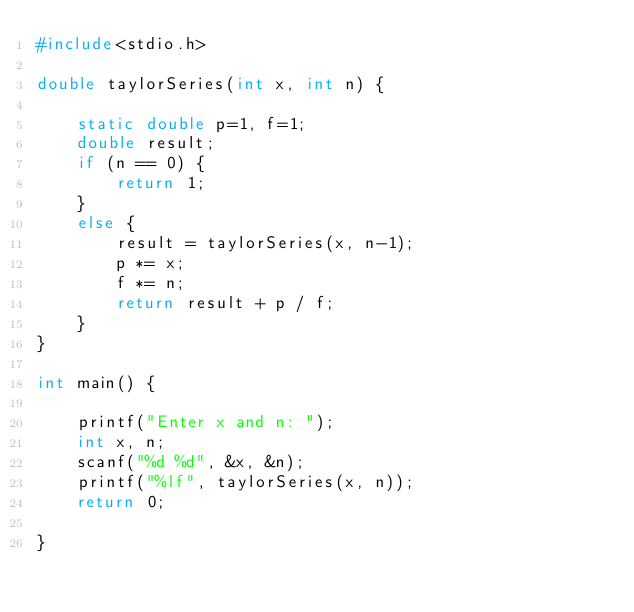Convert code to text. <code><loc_0><loc_0><loc_500><loc_500><_C_>#include<stdio.h>

double taylorSeries(int x, int n) {
	
	static double p=1, f=1;
	double result;
	if (n == 0) {
		return 1;
	}
	else {
		result = taylorSeries(x, n-1);
		p *= x;
		f *= n;
		return result + p / f; 
	}
}

int main() {
	
	printf("Enter x and n: ");
	int x, n;
	scanf("%d %d", &x, &n);
	printf("%lf", taylorSeries(x, n));
	return 0;
	
}
</code> 